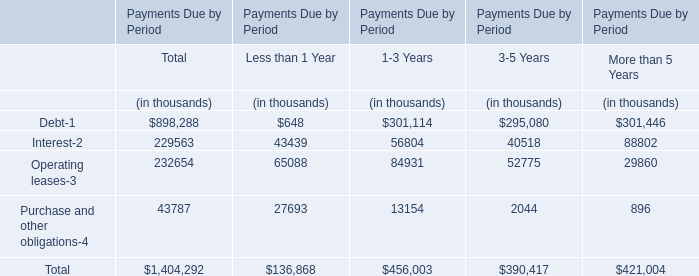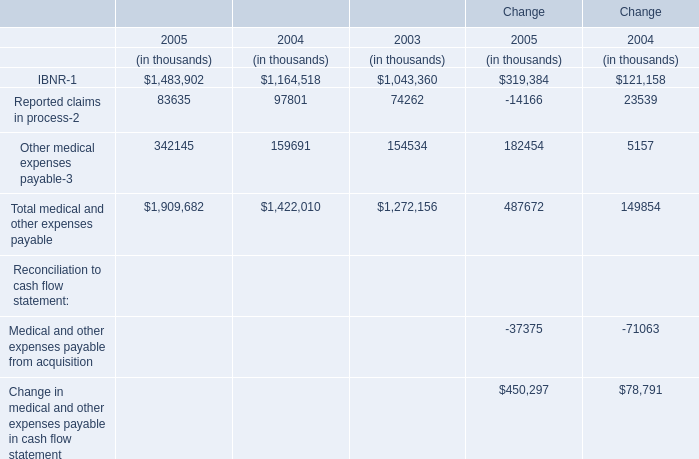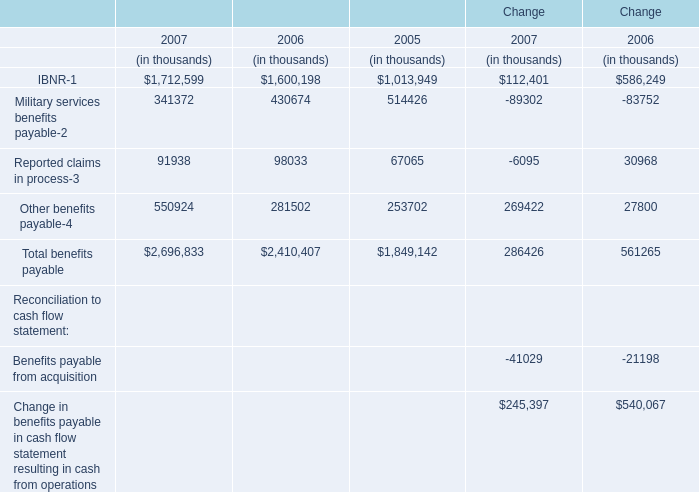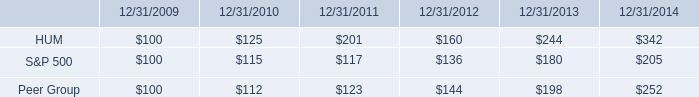If Reported claims in process develops with the same growth rate in 2007, what will it reach in 2008? (in thousand) 
Computations: ((1 + ((91938 - 98033) / 98033)) * 91938)
Answer: 86221.94408. 